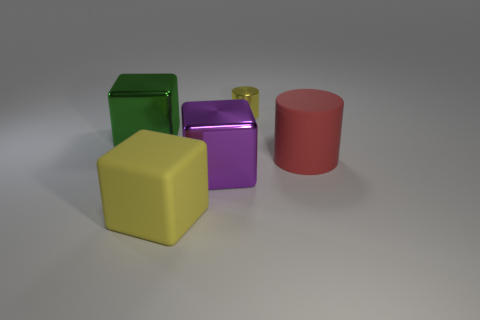Is the material of the block that is to the right of the big yellow matte cube the same as the object to the left of the yellow cube?
Ensure brevity in your answer.  Yes. What is the shape of the matte object that is behind the big rubber object that is in front of the purple object?
Keep it short and to the point. Cylinder. The small cylinder that is the same material as the big purple block is what color?
Offer a very short reply. Yellow. Is the color of the large matte cylinder the same as the tiny thing?
Give a very brief answer. No. What is the shape of the purple thing that is the same size as the yellow matte thing?
Offer a terse response. Cube. What is the size of the yellow cylinder?
Provide a succinct answer. Small. Is the size of the yellow thing that is in front of the purple block the same as the cylinder on the right side of the tiny cylinder?
Your answer should be very brief. Yes. What is the color of the large rubber object left of the cylinder that is right of the tiny metallic thing?
Your response must be concise. Yellow. There is a purple block that is the same size as the yellow block; what is its material?
Offer a very short reply. Metal. What number of shiny objects are big yellow things or big purple balls?
Your answer should be very brief. 0. 